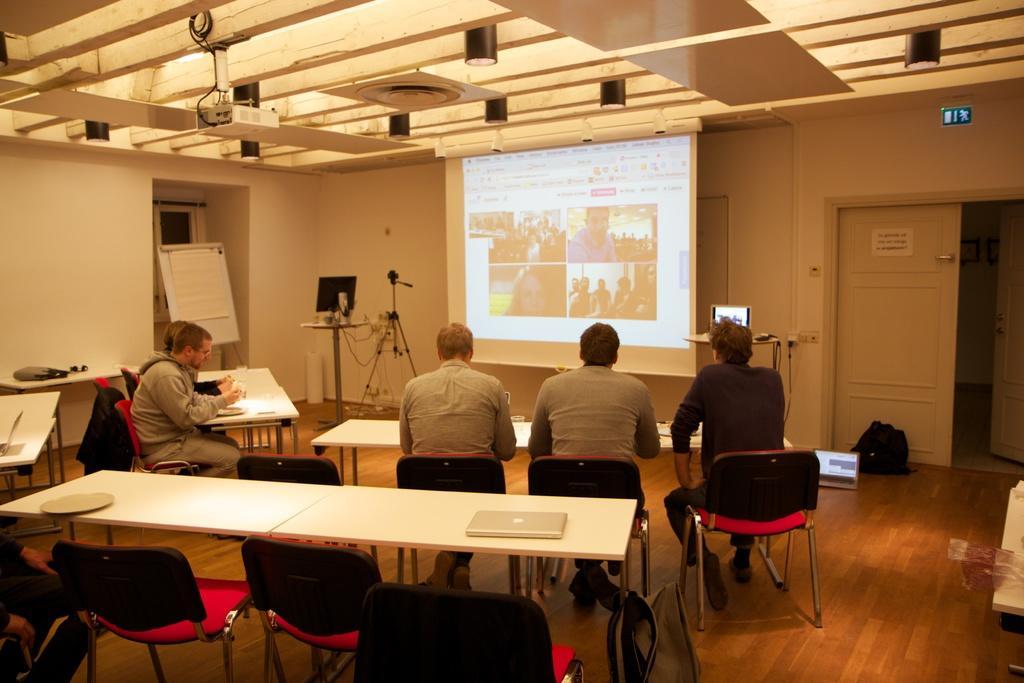In one or two sentences, can you explain what this image depicts? Few people are watching a presentation on a screen. 